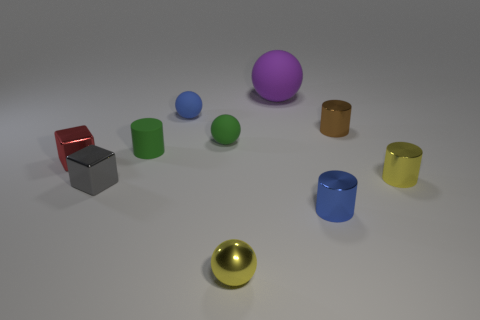What is the material of the object that is the same color as the small shiny ball?
Provide a succinct answer. Metal. There is a tiny thing to the left of the tiny gray thing; what is its material?
Your answer should be compact. Metal. Is there anything else that has the same size as the blue rubber thing?
Your answer should be compact. Yes. Are there any purple rubber things on the right side of the big purple sphere?
Ensure brevity in your answer.  No. There is a small red thing; what shape is it?
Ensure brevity in your answer.  Cube. What number of objects are tiny things to the left of the big matte sphere or yellow matte cubes?
Provide a succinct answer. 6. How many other objects are the same color as the small matte cylinder?
Your answer should be compact. 1. There is a small rubber cylinder; does it have the same color as the rubber object that is to the right of the shiny ball?
Keep it short and to the point. No. There is a small matte object that is the same shape as the brown metal thing; what is its color?
Provide a short and direct response. Green. Does the small gray cube have the same material as the tiny yellow thing that is to the right of the brown cylinder?
Provide a succinct answer. Yes. 